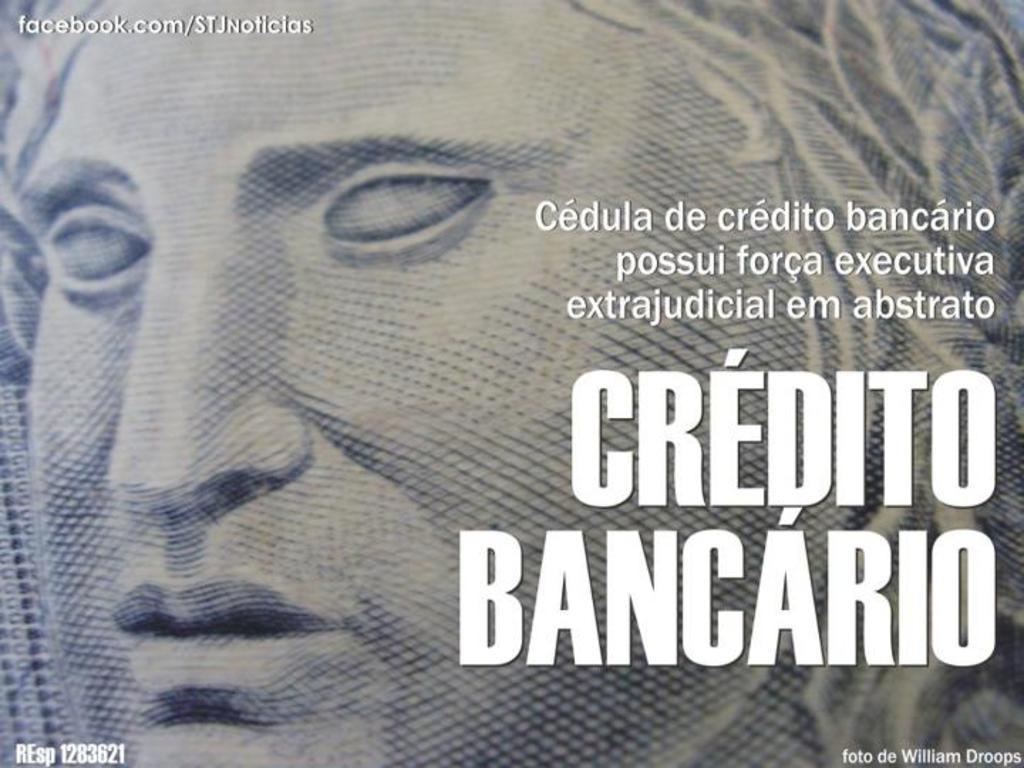What is featured on the poster in the image? The poster contains a person. What else can be seen on the poster besides the person? There is text on the poster. What type of neck can be seen on the person depicted on the poster? There is no neck visible on the person depicted on the poster, as it is a two-dimensional image. What shape is the poster in the image? The shape of the poster cannot be determined from the image alone, as it depends on the perspective and framing of the photograph. 